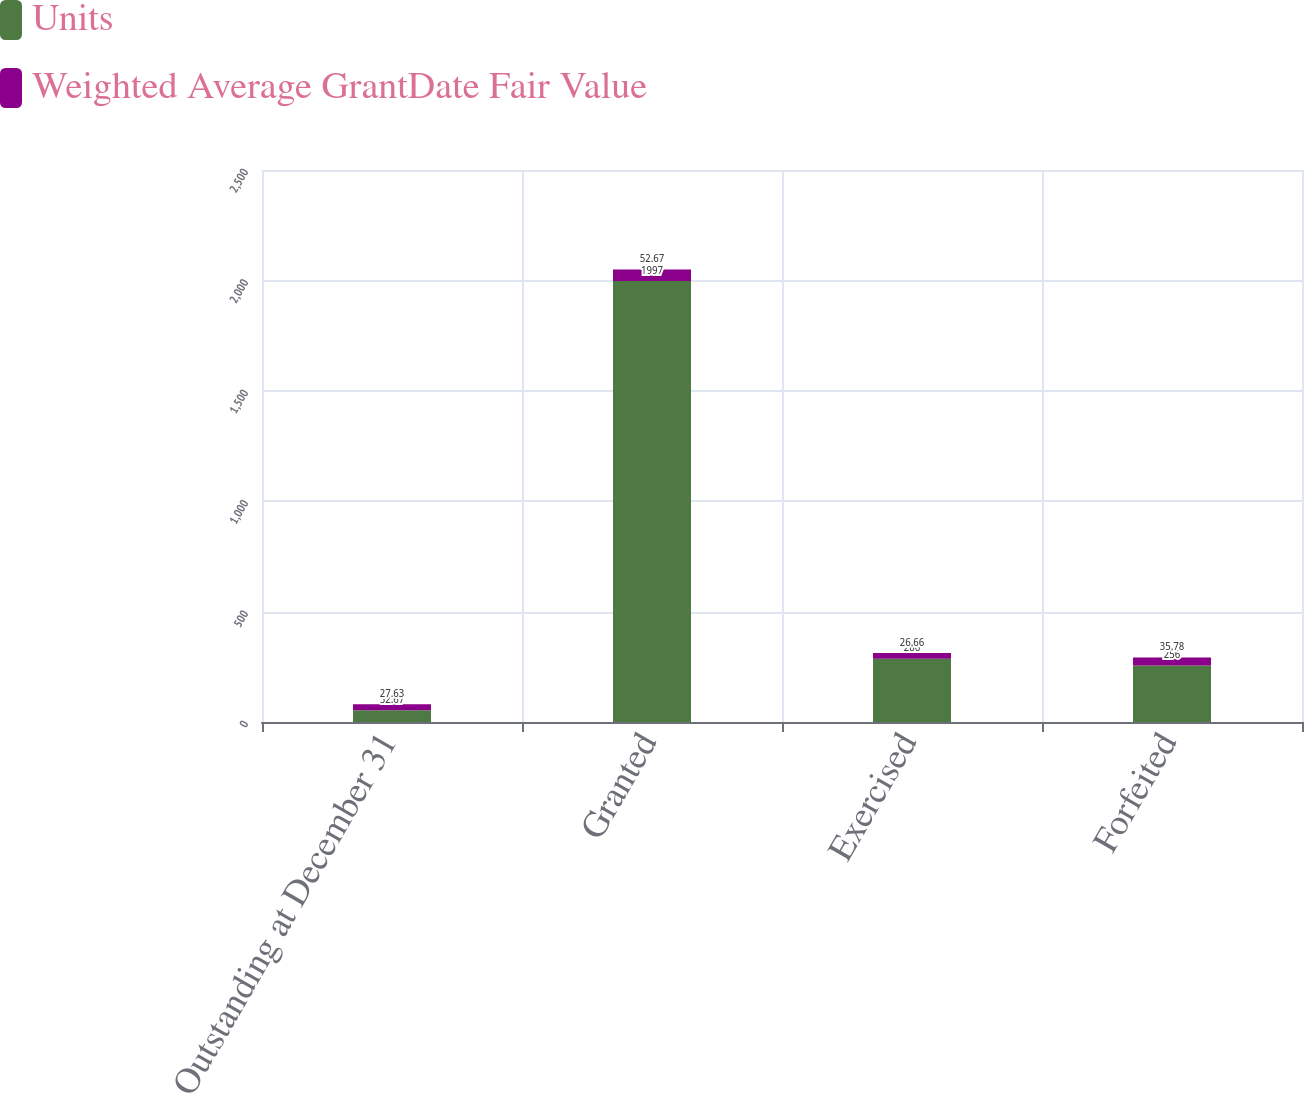Convert chart. <chart><loc_0><loc_0><loc_500><loc_500><stacked_bar_chart><ecel><fcel>Outstanding at December 31<fcel>Granted<fcel>Exercised<fcel>Forfeited<nl><fcel>Units<fcel>52.67<fcel>1997<fcel>286<fcel>256<nl><fcel>Weighted Average GrantDate Fair Value<fcel>27.63<fcel>52.67<fcel>26.66<fcel>35.78<nl></chart> 